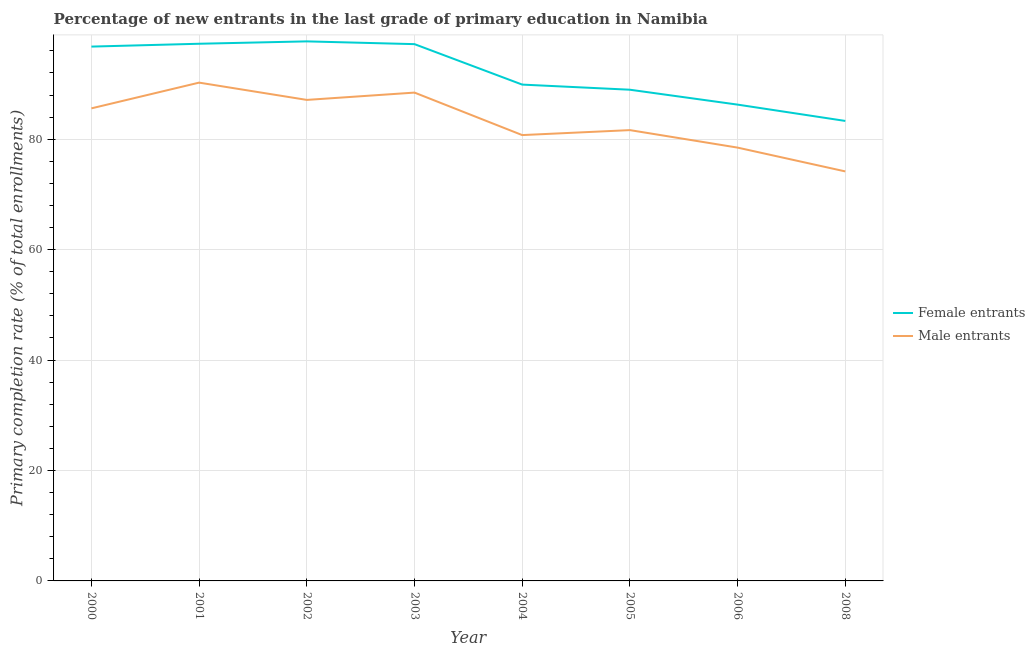Does the line corresponding to primary completion rate of female entrants intersect with the line corresponding to primary completion rate of male entrants?
Your answer should be very brief. No. Is the number of lines equal to the number of legend labels?
Keep it short and to the point. Yes. What is the primary completion rate of female entrants in 2000?
Your answer should be compact. 96.77. Across all years, what is the maximum primary completion rate of female entrants?
Offer a very short reply. 97.71. Across all years, what is the minimum primary completion rate of male entrants?
Keep it short and to the point. 74.16. In which year was the primary completion rate of male entrants maximum?
Provide a short and direct response. 2001. In which year was the primary completion rate of female entrants minimum?
Keep it short and to the point. 2008. What is the total primary completion rate of male entrants in the graph?
Your answer should be compact. 666.39. What is the difference between the primary completion rate of female entrants in 2005 and that in 2006?
Your answer should be compact. 2.7. What is the difference between the primary completion rate of female entrants in 2005 and the primary completion rate of male entrants in 2002?
Your answer should be compact. 1.84. What is the average primary completion rate of male entrants per year?
Offer a terse response. 83.3. In the year 2006, what is the difference between the primary completion rate of male entrants and primary completion rate of female entrants?
Offer a very short reply. -7.79. In how many years, is the primary completion rate of male entrants greater than 16 %?
Ensure brevity in your answer.  8. What is the ratio of the primary completion rate of female entrants in 2004 to that in 2008?
Make the answer very short. 1.08. Is the difference between the primary completion rate of male entrants in 2001 and 2002 greater than the difference between the primary completion rate of female entrants in 2001 and 2002?
Your answer should be compact. Yes. What is the difference between the highest and the second highest primary completion rate of male entrants?
Give a very brief answer. 1.81. What is the difference between the highest and the lowest primary completion rate of male entrants?
Provide a succinct answer. 16.08. Does the primary completion rate of male entrants monotonically increase over the years?
Give a very brief answer. No. Is the primary completion rate of female entrants strictly less than the primary completion rate of male entrants over the years?
Your response must be concise. No. How many lines are there?
Ensure brevity in your answer.  2. What is the difference between two consecutive major ticks on the Y-axis?
Your response must be concise. 20. Are the values on the major ticks of Y-axis written in scientific E-notation?
Give a very brief answer. No. Does the graph contain grids?
Keep it short and to the point. Yes. How are the legend labels stacked?
Provide a short and direct response. Vertical. What is the title of the graph?
Offer a terse response. Percentage of new entrants in the last grade of primary education in Namibia. What is the label or title of the X-axis?
Your response must be concise. Year. What is the label or title of the Y-axis?
Make the answer very short. Primary completion rate (% of total enrollments). What is the Primary completion rate (% of total enrollments) of Female entrants in 2000?
Your answer should be compact. 96.77. What is the Primary completion rate (% of total enrollments) of Male entrants in 2000?
Your answer should be compact. 85.58. What is the Primary completion rate (% of total enrollments) of Female entrants in 2001?
Keep it short and to the point. 97.28. What is the Primary completion rate (% of total enrollments) in Male entrants in 2001?
Your answer should be compact. 90.24. What is the Primary completion rate (% of total enrollments) in Female entrants in 2002?
Offer a terse response. 97.71. What is the Primary completion rate (% of total enrollments) of Male entrants in 2002?
Your answer should be very brief. 87.11. What is the Primary completion rate (% of total enrollments) in Female entrants in 2003?
Your answer should be compact. 97.21. What is the Primary completion rate (% of total enrollments) of Male entrants in 2003?
Ensure brevity in your answer.  88.44. What is the Primary completion rate (% of total enrollments) in Female entrants in 2004?
Give a very brief answer. 89.89. What is the Primary completion rate (% of total enrollments) of Male entrants in 2004?
Offer a terse response. 80.74. What is the Primary completion rate (% of total enrollments) of Female entrants in 2005?
Your answer should be very brief. 88.96. What is the Primary completion rate (% of total enrollments) in Male entrants in 2005?
Your answer should be very brief. 81.64. What is the Primary completion rate (% of total enrollments) in Female entrants in 2006?
Your answer should be very brief. 86.26. What is the Primary completion rate (% of total enrollments) of Male entrants in 2006?
Offer a very short reply. 78.47. What is the Primary completion rate (% of total enrollments) of Female entrants in 2008?
Your response must be concise. 83.3. What is the Primary completion rate (% of total enrollments) in Male entrants in 2008?
Give a very brief answer. 74.16. Across all years, what is the maximum Primary completion rate (% of total enrollments) of Female entrants?
Provide a succinct answer. 97.71. Across all years, what is the maximum Primary completion rate (% of total enrollments) in Male entrants?
Offer a very short reply. 90.24. Across all years, what is the minimum Primary completion rate (% of total enrollments) in Female entrants?
Make the answer very short. 83.3. Across all years, what is the minimum Primary completion rate (% of total enrollments) of Male entrants?
Keep it short and to the point. 74.16. What is the total Primary completion rate (% of total enrollments) of Female entrants in the graph?
Your answer should be very brief. 737.38. What is the total Primary completion rate (% of total enrollments) of Male entrants in the graph?
Your response must be concise. 666.39. What is the difference between the Primary completion rate (% of total enrollments) of Female entrants in 2000 and that in 2001?
Offer a very short reply. -0.52. What is the difference between the Primary completion rate (% of total enrollments) in Male entrants in 2000 and that in 2001?
Provide a short and direct response. -4.66. What is the difference between the Primary completion rate (% of total enrollments) in Female entrants in 2000 and that in 2002?
Your response must be concise. -0.95. What is the difference between the Primary completion rate (% of total enrollments) of Male entrants in 2000 and that in 2002?
Offer a terse response. -1.53. What is the difference between the Primary completion rate (% of total enrollments) of Female entrants in 2000 and that in 2003?
Your response must be concise. -0.45. What is the difference between the Primary completion rate (% of total enrollments) in Male entrants in 2000 and that in 2003?
Your answer should be compact. -2.85. What is the difference between the Primary completion rate (% of total enrollments) in Female entrants in 2000 and that in 2004?
Your answer should be very brief. 6.88. What is the difference between the Primary completion rate (% of total enrollments) of Male entrants in 2000 and that in 2004?
Your answer should be compact. 4.84. What is the difference between the Primary completion rate (% of total enrollments) of Female entrants in 2000 and that in 2005?
Provide a succinct answer. 7.81. What is the difference between the Primary completion rate (% of total enrollments) of Male entrants in 2000 and that in 2005?
Offer a very short reply. 3.94. What is the difference between the Primary completion rate (% of total enrollments) in Female entrants in 2000 and that in 2006?
Give a very brief answer. 10.51. What is the difference between the Primary completion rate (% of total enrollments) of Male entrants in 2000 and that in 2006?
Provide a succinct answer. 7.11. What is the difference between the Primary completion rate (% of total enrollments) in Female entrants in 2000 and that in 2008?
Ensure brevity in your answer.  13.46. What is the difference between the Primary completion rate (% of total enrollments) of Male entrants in 2000 and that in 2008?
Provide a succinct answer. 11.42. What is the difference between the Primary completion rate (% of total enrollments) of Female entrants in 2001 and that in 2002?
Provide a succinct answer. -0.43. What is the difference between the Primary completion rate (% of total enrollments) in Male entrants in 2001 and that in 2002?
Provide a succinct answer. 3.13. What is the difference between the Primary completion rate (% of total enrollments) of Female entrants in 2001 and that in 2003?
Offer a very short reply. 0.07. What is the difference between the Primary completion rate (% of total enrollments) of Male entrants in 2001 and that in 2003?
Your answer should be very brief. 1.81. What is the difference between the Primary completion rate (% of total enrollments) in Female entrants in 2001 and that in 2004?
Give a very brief answer. 7.4. What is the difference between the Primary completion rate (% of total enrollments) in Male entrants in 2001 and that in 2004?
Your answer should be compact. 9.5. What is the difference between the Primary completion rate (% of total enrollments) of Female entrants in 2001 and that in 2005?
Your response must be concise. 8.32. What is the difference between the Primary completion rate (% of total enrollments) of Male entrants in 2001 and that in 2005?
Give a very brief answer. 8.6. What is the difference between the Primary completion rate (% of total enrollments) of Female entrants in 2001 and that in 2006?
Give a very brief answer. 11.02. What is the difference between the Primary completion rate (% of total enrollments) of Male entrants in 2001 and that in 2006?
Your response must be concise. 11.77. What is the difference between the Primary completion rate (% of total enrollments) of Female entrants in 2001 and that in 2008?
Offer a terse response. 13.98. What is the difference between the Primary completion rate (% of total enrollments) of Male entrants in 2001 and that in 2008?
Your answer should be compact. 16.08. What is the difference between the Primary completion rate (% of total enrollments) in Male entrants in 2002 and that in 2003?
Offer a very short reply. -1.32. What is the difference between the Primary completion rate (% of total enrollments) in Female entrants in 2002 and that in 2004?
Keep it short and to the point. 7.83. What is the difference between the Primary completion rate (% of total enrollments) of Male entrants in 2002 and that in 2004?
Offer a very short reply. 6.37. What is the difference between the Primary completion rate (% of total enrollments) in Female entrants in 2002 and that in 2005?
Ensure brevity in your answer.  8.76. What is the difference between the Primary completion rate (% of total enrollments) of Male entrants in 2002 and that in 2005?
Provide a short and direct response. 5.47. What is the difference between the Primary completion rate (% of total enrollments) of Female entrants in 2002 and that in 2006?
Your answer should be compact. 11.45. What is the difference between the Primary completion rate (% of total enrollments) of Male entrants in 2002 and that in 2006?
Offer a terse response. 8.64. What is the difference between the Primary completion rate (% of total enrollments) in Female entrants in 2002 and that in 2008?
Offer a terse response. 14.41. What is the difference between the Primary completion rate (% of total enrollments) in Male entrants in 2002 and that in 2008?
Offer a very short reply. 12.95. What is the difference between the Primary completion rate (% of total enrollments) of Female entrants in 2003 and that in 2004?
Provide a succinct answer. 7.33. What is the difference between the Primary completion rate (% of total enrollments) in Male entrants in 2003 and that in 2004?
Provide a succinct answer. 7.69. What is the difference between the Primary completion rate (% of total enrollments) of Female entrants in 2003 and that in 2005?
Provide a succinct answer. 8.26. What is the difference between the Primary completion rate (% of total enrollments) in Male entrants in 2003 and that in 2005?
Your response must be concise. 6.8. What is the difference between the Primary completion rate (% of total enrollments) of Female entrants in 2003 and that in 2006?
Keep it short and to the point. 10.95. What is the difference between the Primary completion rate (% of total enrollments) in Male entrants in 2003 and that in 2006?
Offer a very short reply. 9.96. What is the difference between the Primary completion rate (% of total enrollments) in Female entrants in 2003 and that in 2008?
Provide a succinct answer. 13.91. What is the difference between the Primary completion rate (% of total enrollments) of Male entrants in 2003 and that in 2008?
Keep it short and to the point. 14.27. What is the difference between the Primary completion rate (% of total enrollments) in Female entrants in 2004 and that in 2005?
Make the answer very short. 0.93. What is the difference between the Primary completion rate (% of total enrollments) of Male entrants in 2004 and that in 2005?
Keep it short and to the point. -0.9. What is the difference between the Primary completion rate (% of total enrollments) of Female entrants in 2004 and that in 2006?
Make the answer very short. 3.63. What is the difference between the Primary completion rate (% of total enrollments) in Male entrants in 2004 and that in 2006?
Keep it short and to the point. 2.27. What is the difference between the Primary completion rate (% of total enrollments) of Female entrants in 2004 and that in 2008?
Offer a terse response. 6.58. What is the difference between the Primary completion rate (% of total enrollments) in Male entrants in 2004 and that in 2008?
Ensure brevity in your answer.  6.58. What is the difference between the Primary completion rate (% of total enrollments) of Female entrants in 2005 and that in 2006?
Offer a very short reply. 2.7. What is the difference between the Primary completion rate (% of total enrollments) in Male entrants in 2005 and that in 2006?
Offer a terse response. 3.17. What is the difference between the Primary completion rate (% of total enrollments) of Female entrants in 2005 and that in 2008?
Your response must be concise. 5.65. What is the difference between the Primary completion rate (% of total enrollments) in Male entrants in 2005 and that in 2008?
Give a very brief answer. 7.48. What is the difference between the Primary completion rate (% of total enrollments) in Female entrants in 2006 and that in 2008?
Give a very brief answer. 2.96. What is the difference between the Primary completion rate (% of total enrollments) of Male entrants in 2006 and that in 2008?
Offer a terse response. 4.31. What is the difference between the Primary completion rate (% of total enrollments) of Female entrants in 2000 and the Primary completion rate (% of total enrollments) of Male entrants in 2001?
Keep it short and to the point. 6.52. What is the difference between the Primary completion rate (% of total enrollments) in Female entrants in 2000 and the Primary completion rate (% of total enrollments) in Male entrants in 2002?
Ensure brevity in your answer.  9.65. What is the difference between the Primary completion rate (% of total enrollments) in Female entrants in 2000 and the Primary completion rate (% of total enrollments) in Male entrants in 2003?
Provide a succinct answer. 8.33. What is the difference between the Primary completion rate (% of total enrollments) of Female entrants in 2000 and the Primary completion rate (% of total enrollments) of Male entrants in 2004?
Offer a very short reply. 16.02. What is the difference between the Primary completion rate (% of total enrollments) in Female entrants in 2000 and the Primary completion rate (% of total enrollments) in Male entrants in 2005?
Provide a short and direct response. 15.13. What is the difference between the Primary completion rate (% of total enrollments) in Female entrants in 2000 and the Primary completion rate (% of total enrollments) in Male entrants in 2006?
Provide a succinct answer. 18.29. What is the difference between the Primary completion rate (% of total enrollments) of Female entrants in 2000 and the Primary completion rate (% of total enrollments) of Male entrants in 2008?
Your answer should be very brief. 22.6. What is the difference between the Primary completion rate (% of total enrollments) of Female entrants in 2001 and the Primary completion rate (% of total enrollments) of Male entrants in 2002?
Make the answer very short. 10.17. What is the difference between the Primary completion rate (% of total enrollments) of Female entrants in 2001 and the Primary completion rate (% of total enrollments) of Male entrants in 2003?
Give a very brief answer. 8.84. What is the difference between the Primary completion rate (% of total enrollments) of Female entrants in 2001 and the Primary completion rate (% of total enrollments) of Male entrants in 2004?
Offer a terse response. 16.54. What is the difference between the Primary completion rate (% of total enrollments) of Female entrants in 2001 and the Primary completion rate (% of total enrollments) of Male entrants in 2005?
Your answer should be very brief. 15.64. What is the difference between the Primary completion rate (% of total enrollments) of Female entrants in 2001 and the Primary completion rate (% of total enrollments) of Male entrants in 2006?
Your answer should be compact. 18.81. What is the difference between the Primary completion rate (% of total enrollments) in Female entrants in 2001 and the Primary completion rate (% of total enrollments) in Male entrants in 2008?
Provide a succinct answer. 23.12. What is the difference between the Primary completion rate (% of total enrollments) in Female entrants in 2002 and the Primary completion rate (% of total enrollments) in Male entrants in 2003?
Your answer should be very brief. 9.28. What is the difference between the Primary completion rate (% of total enrollments) of Female entrants in 2002 and the Primary completion rate (% of total enrollments) of Male entrants in 2004?
Offer a terse response. 16.97. What is the difference between the Primary completion rate (% of total enrollments) in Female entrants in 2002 and the Primary completion rate (% of total enrollments) in Male entrants in 2005?
Your answer should be very brief. 16.07. What is the difference between the Primary completion rate (% of total enrollments) in Female entrants in 2002 and the Primary completion rate (% of total enrollments) in Male entrants in 2006?
Your answer should be compact. 19.24. What is the difference between the Primary completion rate (% of total enrollments) of Female entrants in 2002 and the Primary completion rate (% of total enrollments) of Male entrants in 2008?
Give a very brief answer. 23.55. What is the difference between the Primary completion rate (% of total enrollments) in Female entrants in 2003 and the Primary completion rate (% of total enrollments) in Male entrants in 2004?
Your answer should be compact. 16.47. What is the difference between the Primary completion rate (% of total enrollments) of Female entrants in 2003 and the Primary completion rate (% of total enrollments) of Male entrants in 2005?
Provide a succinct answer. 15.57. What is the difference between the Primary completion rate (% of total enrollments) of Female entrants in 2003 and the Primary completion rate (% of total enrollments) of Male entrants in 2006?
Ensure brevity in your answer.  18.74. What is the difference between the Primary completion rate (% of total enrollments) of Female entrants in 2003 and the Primary completion rate (% of total enrollments) of Male entrants in 2008?
Your response must be concise. 23.05. What is the difference between the Primary completion rate (% of total enrollments) of Female entrants in 2004 and the Primary completion rate (% of total enrollments) of Male entrants in 2005?
Give a very brief answer. 8.24. What is the difference between the Primary completion rate (% of total enrollments) of Female entrants in 2004 and the Primary completion rate (% of total enrollments) of Male entrants in 2006?
Your response must be concise. 11.41. What is the difference between the Primary completion rate (% of total enrollments) of Female entrants in 2004 and the Primary completion rate (% of total enrollments) of Male entrants in 2008?
Keep it short and to the point. 15.72. What is the difference between the Primary completion rate (% of total enrollments) of Female entrants in 2005 and the Primary completion rate (% of total enrollments) of Male entrants in 2006?
Your answer should be very brief. 10.48. What is the difference between the Primary completion rate (% of total enrollments) of Female entrants in 2005 and the Primary completion rate (% of total enrollments) of Male entrants in 2008?
Provide a short and direct response. 14.8. What is the difference between the Primary completion rate (% of total enrollments) in Female entrants in 2006 and the Primary completion rate (% of total enrollments) in Male entrants in 2008?
Offer a terse response. 12.1. What is the average Primary completion rate (% of total enrollments) in Female entrants per year?
Offer a very short reply. 92.17. What is the average Primary completion rate (% of total enrollments) of Male entrants per year?
Give a very brief answer. 83.3. In the year 2000, what is the difference between the Primary completion rate (% of total enrollments) of Female entrants and Primary completion rate (% of total enrollments) of Male entrants?
Make the answer very short. 11.18. In the year 2001, what is the difference between the Primary completion rate (% of total enrollments) in Female entrants and Primary completion rate (% of total enrollments) in Male entrants?
Keep it short and to the point. 7.04. In the year 2002, what is the difference between the Primary completion rate (% of total enrollments) in Female entrants and Primary completion rate (% of total enrollments) in Male entrants?
Provide a short and direct response. 10.6. In the year 2003, what is the difference between the Primary completion rate (% of total enrollments) of Female entrants and Primary completion rate (% of total enrollments) of Male entrants?
Provide a short and direct response. 8.78. In the year 2004, what is the difference between the Primary completion rate (% of total enrollments) of Female entrants and Primary completion rate (% of total enrollments) of Male entrants?
Provide a short and direct response. 9.14. In the year 2005, what is the difference between the Primary completion rate (% of total enrollments) in Female entrants and Primary completion rate (% of total enrollments) in Male entrants?
Make the answer very short. 7.32. In the year 2006, what is the difference between the Primary completion rate (% of total enrollments) in Female entrants and Primary completion rate (% of total enrollments) in Male entrants?
Ensure brevity in your answer.  7.79. In the year 2008, what is the difference between the Primary completion rate (% of total enrollments) in Female entrants and Primary completion rate (% of total enrollments) in Male entrants?
Give a very brief answer. 9.14. What is the ratio of the Primary completion rate (% of total enrollments) of Female entrants in 2000 to that in 2001?
Ensure brevity in your answer.  0.99. What is the ratio of the Primary completion rate (% of total enrollments) of Male entrants in 2000 to that in 2001?
Your answer should be compact. 0.95. What is the ratio of the Primary completion rate (% of total enrollments) of Female entrants in 2000 to that in 2002?
Keep it short and to the point. 0.99. What is the ratio of the Primary completion rate (% of total enrollments) in Male entrants in 2000 to that in 2002?
Offer a terse response. 0.98. What is the ratio of the Primary completion rate (% of total enrollments) in Female entrants in 2000 to that in 2004?
Provide a short and direct response. 1.08. What is the ratio of the Primary completion rate (% of total enrollments) in Male entrants in 2000 to that in 2004?
Offer a terse response. 1.06. What is the ratio of the Primary completion rate (% of total enrollments) in Female entrants in 2000 to that in 2005?
Your answer should be compact. 1.09. What is the ratio of the Primary completion rate (% of total enrollments) of Male entrants in 2000 to that in 2005?
Your response must be concise. 1.05. What is the ratio of the Primary completion rate (% of total enrollments) of Female entrants in 2000 to that in 2006?
Provide a succinct answer. 1.12. What is the ratio of the Primary completion rate (% of total enrollments) of Male entrants in 2000 to that in 2006?
Offer a terse response. 1.09. What is the ratio of the Primary completion rate (% of total enrollments) of Female entrants in 2000 to that in 2008?
Your response must be concise. 1.16. What is the ratio of the Primary completion rate (% of total enrollments) of Male entrants in 2000 to that in 2008?
Your answer should be very brief. 1.15. What is the ratio of the Primary completion rate (% of total enrollments) in Female entrants in 2001 to that in 2002?
Provide a short and direct response. 1. What is the ratio of the Primary completion rate (% of total enrollments) in Male entrants in 2001 to that in 2002?
Make the answer very short. 1.04. What is the ratio of the Primary completion rate (% of total enrollments) in Male entrants in 2001 to that in 2003?
Make the answer very short. 1.02. What is the ratio of the Primary completion rate (% of total enrollments) in Female entrants in 2001 to that in 2004?
Your answer should be compact. 1.08. What is the ratio of the Primary completion rate (% of total enrollments) in Male entrants in 2001 to that in 2004?
Provide a short and direct response. 1.12. What is the ratio of the Primary completion rate (% of total enrollments) in Female entrants in 2001 to that in 2005?
Your response must be concise. 1.09. What is the ratio of the Primary completion rate (% of total enrollments) in Male entrants in 2001 to that in 2005?
Give a very brief answer. 1.11. What is the ratio of the Primary completion rate (% of total enrollments) in Female entrants in 2001 to that in 2006?
Offer a terse response. 1.13. What is the ratio of the Primary completion rate (% of total enrollments) in Male entrants in 2001 to that in 2006?
Your answer should be compact. 1.15. What is the ratio of the Primary completion rate (% of total enrollments) in Female entrants in 2001 to that in 2008?
Your response must be concise. 1.17. What is the ratio of the Primary completion rate (% of total enrollments) in Male entrants in 2001 to that in 2008?
Ensure brevity in your answer.  1.22. What is the ratio of the Primary completion rate (% of total enrollments) of Female entrants in 2002 to that in 2003?
Your answer should be very brief. 1.01. What is the ratio of the Primary completion rate (% of total enrollments) in Female entrants in 2002 to that in 2004?
Make the answer very short. 1.09. What is the ratio of the Primary completion rate (% of total enrollments) in Male entrants in 2002 to that in 2004?
Your answer should be compact. 1.08. What is the ratio of the Primary completion rate (% of total enrollments) in Female entrants in 2002 to that in 2005?
Make the answer very short. 1.1. What is the ratio of the Primary completion rate (% of total enrollments) of Male entrants in 2002 to that in 2005?
Your response must be concise. 1.07. What is the ratio of the Primary completion rate (% of total enrollments) of Female entrants in 2002 to that in 2006?
Your answer should be compact. 1.13. What is the ratio of the Primary completion rate (% of total enrollments) in Male entrants in 2002 to that in 2006?
Make the answer very short. 1.11. What is the ratio of the Primary completion rate (% of total enrollments) in Female entrants in 2002 to that in 2008?
Offer a very short reply. 1.17. What is the ratio of the Primary completion rate (% of total enrollments) of Male entrants in 2002 to that in 2008?
Keep it short and to the point. 1.17. What is the ratio of the Primary completion rate (% of total enrollments) of Female entrants in 2003 to that in 2004?
Your answer should be very brief. 1.08. What is the ratio of the Primary completion rate (% of total enrollments) of Male entrants in 2003 to that in 2004?
Your answer should be compact. 1.1. What is the ratio of the Primary completion rate (% of total enrollments) of Female entrants in 2003 to that in 2005?
Provide a succinct answer. 1.09. What is the ratio of the Primary completion rate (% of total enrollments) of Male entrants in 2003 to that in 2005?
Provide a succinct answer. 1.08. What is the ratio of the Primary completion rate (% of total enrollments) of Female entrants in 2003 to that in 2006?
Your answer should be compact. 1.13. What is the ratio of the Primary completion rate (% of total enrollments) in Male entrants in 2003 to that in 2006?
Make the answer very short. 1.13. What is the ratio of the Primary completion rate (% of total enrollments) of Female entrants in 2003 to that in 2008?
Keep it short and to the point. 1.17. What is the ratio of the Primary completion rate (% of total enrollments) in Male entrants in 2003 to that in 2008?
Provide a short and direct response. 1.19. What is the ratio of the Primary completion rate (% of total enrollments) in Female entrants in 2004 to that in 2005?
Ensure brevity in your answer.  1.01. What is the ratio of the Primary completion rate (% of total enrollments) of Female entrants in 2004 to that in 2006?
Provide a succinct answer. 1.04. What is the ratio of the Primary completion rate (% of total enrollments) in Male entrants in 2004 to that in 2006?
Your answer should be very brief. 1.03. What is the ratio of the Primary completion rate (% of total enrollments) of Female entrants in 2004 to that in 2008?
Keep it short and to the point. 1.08. What is the ratio of the Primary completion rate (% of total enrollments) in Male entrants in 2004 to that in 2008?
Provide a succinct answer. 1.09. What is the ratio of the Primary completion rate (% of total enrollments) of Female entrants in 2005 to that in 2006?
Provide a short and direct response. 1.03. What is the ratio of the Primary completion rate (% of total enrollments) of Male entrants in 2005 to that in 2006?
Provide a succinct answer. 1.04. What is the ratio of the Primary completion rate (% of total enrollments) in Female entrants in 2005 to that in 2008?
Ensure brevity in your answer.  1.07. What is the ratio of the Primary completion rate (% of total enrollments) in Male entrants in 2005 to that in 2008?
Keep it short and to the point. 1.1. What is the ratio of the Primary completion rate (% of total enrollments) in Female entrants in 2006 to that in 2008?
Your answer should be compact. 1.04. What is the ratio of the Primary completion rate (% of total enrollments) of Male entrants in 2006 to that in 2008?
Provide a succinct answer. 1.06. What is the difference between the highest and the second highest Primary completion rate (% of total enrollments) in Female entrants?
Give a very brief answer. 0.43. What is the difference between the highest and the second highest Primary completion rate (% of total enrollments) in Male entrants?
Offer a very short reply. 1.81. What is the difference between the highest and the lowest Primary completion rate (% of total enrollments) in Female entrants?
Ensure brevity in your answer.  14.41. What is the difference between the highest and the lowest Primary completion rate (% of total enrollments) in Male entrants?
Keep it short and to the point. 16.08. 